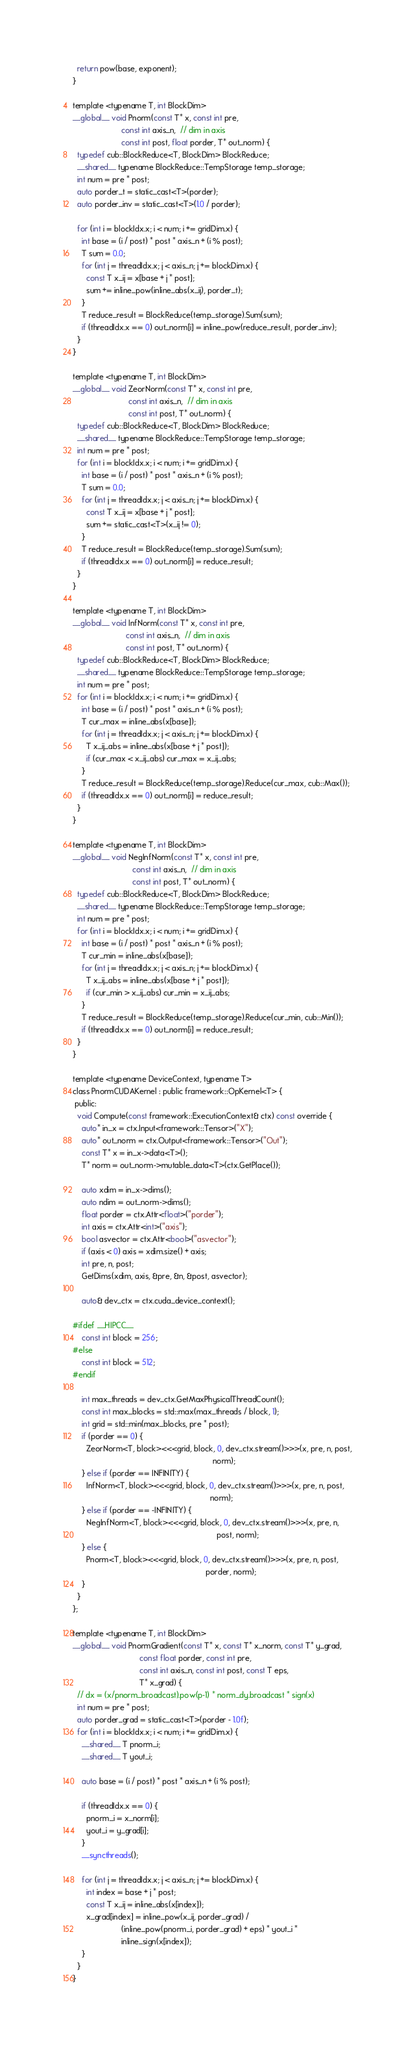Convert code to text. <code><loc_0><loc_0><loc_500><loc_500><_Cuda_>  return pow(base, exponent);
}

template <typename T, int BlockDim>
__global__ void Pnorm(const T* x, const int pre,
                      const int axis_n,  // dim in axis
                      const int post, float porder, T* out_norm) {
  typedef cub::BlockReduce<T, BlockDim> BlockReduce;
  __shared__ typename BlockReduce::TempStorage temp_storage;
  int num = pre * post;
  auto porder_t = static_cast<T>(porder);
  auto porder_inv = static_cast<T>(1.0 / porder);

  for (int i = blockIdx.x; i < num; i += gridDim.x) {
    int base = (i / post) * post * axis_n + (i % post);
    T sum = 0.0;
    for (int j = threadIdx.x; j < axis_n; j += blockDim.x) {
      const T x_ij = x[base + j * post];
      sum += inline_pow(inline_abs(x_ij), porder_t);
    }
    T reduce_result = BlockReduce(temp_storage).Sum(sum);
    if (threadIdx.x == 0) out_norm[i] = inline_pow(reduce_result, porder_inv);
  }
}

template <typename T, int BlockDim>
__global__ void ZeorNorm(const T* x, const int pre,
                         const int axis_n,  // dim in axis
                         const int post, T* out_norm) {
  typedef cub::BlockReduce<T, BlockDim> BlockReduce;
  __shared__ typename BlockReduce::TempStorage temp_storage;
  int num = pre * post;
  for (int i = blockIdx.x; i < num; i += gridDim.x) {
    int base = (i / post) * post * axis_n + (i % post);
    T sum = 0.0;
    for (int j = threadIdx.x; j < axis_n; j += blockDim.x) {
      const T x_ij = x[base + j * post];
      sum += static_cast<T>(x_ij != 0);
    }
    T reduce_result = BlockReduce(temp_storage).Sum(sum);
    if (threadIdx.x == 0) out_norm[i] = reduce_result;
  }
}

template <typename T, int BlockDim>
__global__ void InfNorm(const T* x, const int pre,
                        const int axis_n,  // dim in axis
                        const int post, T* out_norm) {
  typedef cub::BlockReduce<T, BlockDim> BlockReduce;
  __shared__ typename BlockReduce::TempStorage temp_storage;
  int num = pre * post;
  for (int i = blockIdx.x; i < num; i += gridDim.x) {
    int base = (i / post) * post * axis_n + (i % post);
    T cur_max = inline_abs(x[base]);
    for (int j = threadIdx.x; j < axis_n; j += blockDim.x) {
      T x_ij_abs = inline_abs(x[base + j * post]);
      if (cur_max < x_ij_abs) cur_max = x_ij_abs;
    }
    T reduce_result = BlockReduce(temp_storage).Reduce(cur_max, cub::Max());
    if (threadIdx.x == 0) out_norm[i] = reduce_result;
  }
}

template <typename T, int BlockDim>
__global__ void NegInfNorm(const T* x, const int pre,
                           const int axis_n,  // dim in axis
                           const int post, T* out_norm) {
  typedef cub::BlockReduce<T, BlockDim> BlockReduce;
  __shared__ typename BlockReduce::TempStorage temp_storage;
  int num = pre * post;
  for (int i = blockIdx.x; i < num; i += gridDim.x) {
    int base = (i / post) * post * axis_n + (i % post);
    T cur_min = inline_abs(x[base]);
    for (int j = threadIdx.x; j < axis_n; j += blockDim.x) {
      T x_ij_abs = inline_abs(x[base + j * post]);
      if (cur_min > x_ij_abs) cur_min = x_ij_abs;
    }
    T reduce_result = BlockReduce(temp_storage).Reduce(cur_min, cub::Min());
    if (threadIdx.x == 0) out_norm[i] = reduce_result;
  }
}

template <typename DeviceContext, typename T>
class PnormCUDAKernel : public framework::OpKernel<T> {
 public:
  void Compute(const framework::ExecutionContext& ctx) const override {
    auto* in_x = ctx.Input<framework::Tensor>("X");
    auto* out_norm = ctx.Output<framework::Tensor>("Out");
    const T* x = in_x->data<T>();
    T* norm = out_norm->mutable_data<T>(ctx.GetPlace());

    auto xdim = in_x->dims();
    auto ndim = out_norm->dims();
    float porder = ctx.Attr<float>("porder");
    int axis = ctx.Attr<int>("axis");
    bool asvector = ctx.Attr<bool>("asvector");
    if (axis < 0) axis = xdim.size() + axis;
    int pre, n, post;
    GetDims(xdim, axis, &pre, &n, &post, asvector);

    auto& dev_ctx = ctx.cuda_device_context();

#ifdef __HIPCC__
    const int block = 256;
#else
    const int block = 512;
#endif

    int max_threads = dev_ctx.GetMaxPhysicalThreadCount();
    const int max_blocks = std::max(max_threads / block, 1);
    int grid = std::min(max_blocks, pre * post);
    if (porder == 0) {
      ZeorNorm<T, block><<<grid, block, 0, dev_ctx.stream()>>>(x, pre, n, post,
                                                               norm);
    } else if (porder == INFINITY) {
      InfNorm<T, block><<<grid, block, 0, dev_ctx.stream()>>>(x, pre, n, post,
                                                              norm);
    } else if (porder == -INFINITY) {
      NegInfNorm<T, block><<<grid, block, 0, dev_ctx.stream()>>>(x, pre, n,
                                                                 post, norm);
    } else {
      Pnorm<T, block><<<grid, block, 0, dev_ctx.stream()>>>(x, pre, n, post,
                                                            porder, norm);
    }
  }
};

template <typename T, int BlockDim>
__global__ void PnormGradient(const T* x, const T* x_norm, const T* y_grad,
                              const float porder, const int pre,
                              const int axis_n, const int post, const T eps,
                              T* x_grad) {
  // dx = (x/pnorm_broadcast).pow(p-1) * norm_dy.broadcast * sign(x)
  int num = pre * post;
  auto porder_grad = static_cast<T>(porder - 1.0f);
  for (int i = blockIdx.x; i < num; i += gridDim.x) {
    __shared__ T pnorm_i;
    __shared__ T yout_i;

    auto base = (i / post) * post * axis_n + (i % post);

    if (threadIdx.x == 0) {
      pnorm_i = x_norm[i];
      yout_i = y_grad[i];
    }
    __syncthreads();

    for (int j = threadIdx.x; j < axis_n; j += blockDim.x) {
      int index = base + j * post;
      const T x_ij = inline_abs(x[index]);
      x_grad[index] = inline_pow(x_ij, porder_grad) /
                      (inline_pow(pnorm_i, porder_grad) + eps) * yout_i *
                      inline_sign(x[index]);
    }
  }
}
</code> 